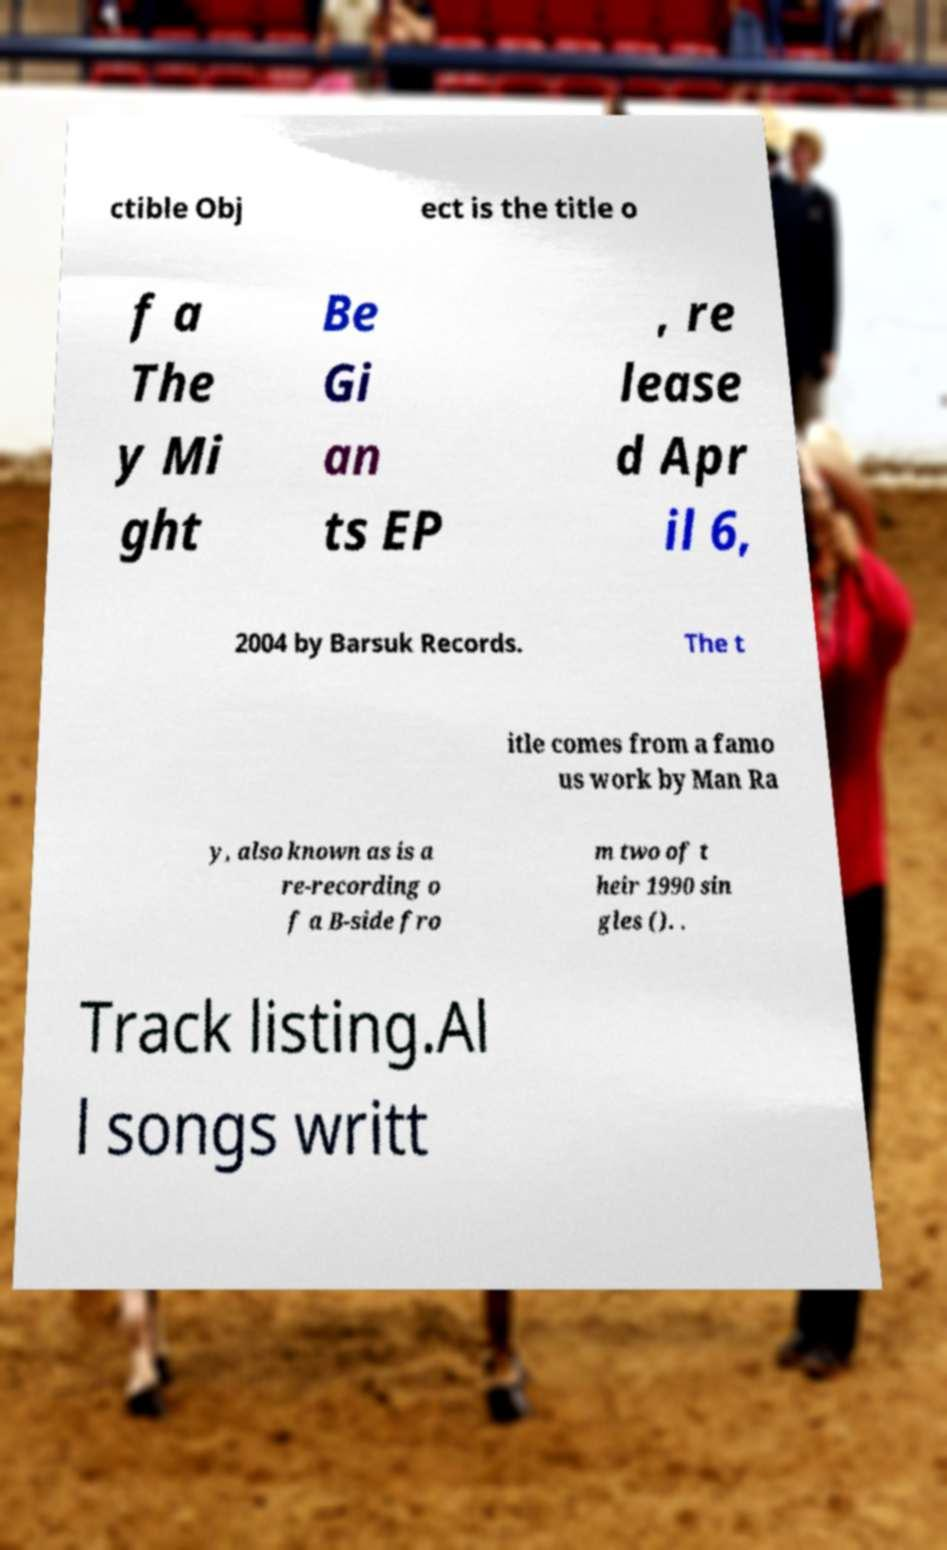I need the written content from this picture converted into text. Can you do that? ctible Obj ect is the title o f a The y Mi ght Be Gi an ts EP , re lease d Apr il 6, 2004 by Barsuk Records. The t itle comes from a famo us work by Man Ra y, also known as is a re-recording o f a B-side fro m two of t heir 1990 sin gles (). . Track listing.Al l songs writt 